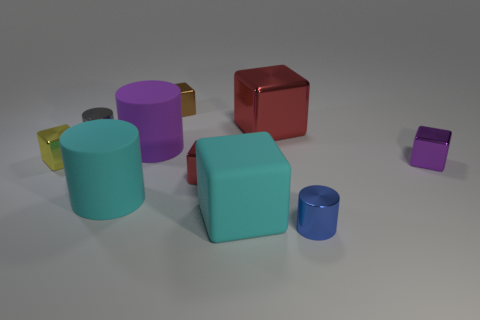Subtract all purple cubes. How many cubes are left? 5 Subtract all big red metal cubes. How many cubes are left? 5 Subtract all yellow cubes. Subtract all cyan balls. How many cubes are left? 5 Subtract all cubes. How many objects are left? 4 Add 8 small purple metal objects. How many small purple metal objects exist? 9 Subtract 2 red blocks. How many objects are left? 8 Subtract all big cyan rubber cylinders. Subtract all big rubber cylinders. How many objects are left? 7 Add 5 large things. How many large things are left? 9 